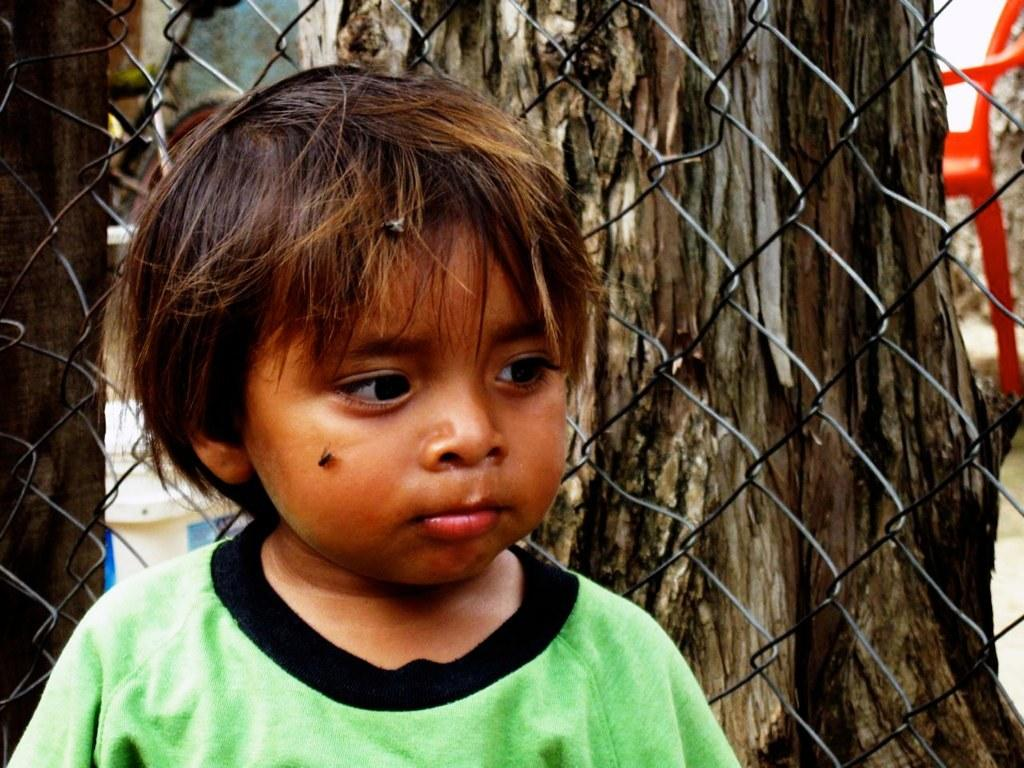Who is present in the image? There is a boy in the image. What is the boy wearing? The boy is wearing a green T-shirt. What can be seen in the background of the image? There is a tree trunk and a bicycle in the background of the image. What object is present in the image that might be used for sitting? There is a chair in the image. What type of barrier is visible in the image? There is a fence in the image. What type of sheet is draped over the bicycle in the image? There is no sheet present in the image, and the bicycle is not covered. What sound can be heard coming from the whistle in the image? There is no whistle present in the image, so no sound can be heard. 